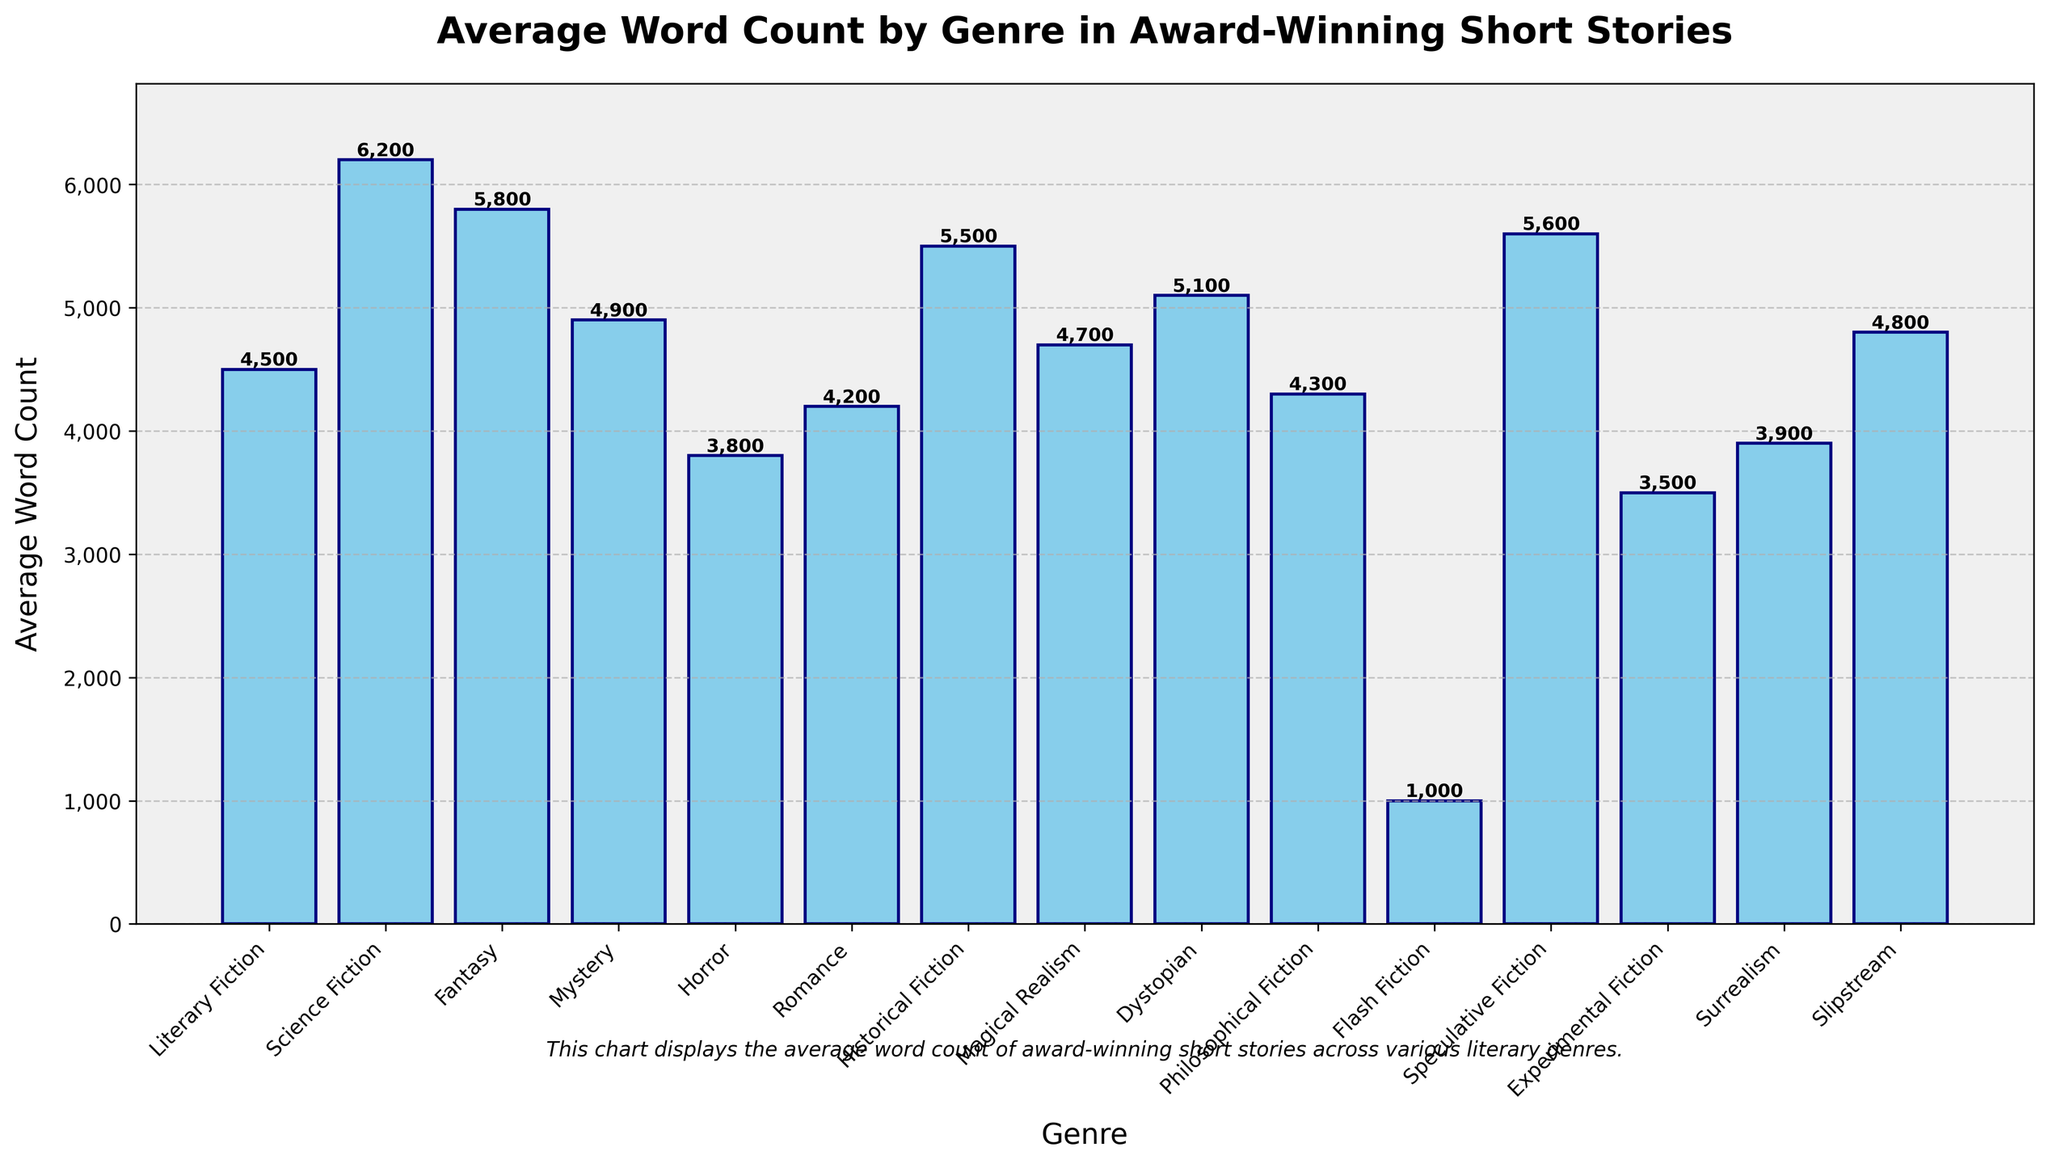What genre has the highest average word count? Look at the height of the bars and identify the tallest one. The tallest bar represents Science Fiction with 6200 words.
Answer: Science Fiction What is the difference in average word count between Science Fiction and Horror? Find the heights of the bars for Science Fiction (6200) and Horror (3800), then subtract the lower from the higher: 6200 - 3800 = 2400.
Answer: 2400 Which genre has a lower average word count, Fantasy or Dystopian? Compare the heights of the bars for Fantasy (5800) and Dystopian (5100). Fantasy is higher, so Dystopian is lower.
Answer: Dystopian How does the average word count of Flash Fiction compare to the other genres? Flash Fiction has an average word count of 1000, which is significantly lower than any other genre in the graph.
Answer: Much lower What are the three genres with the closest average word counts? Look for bars with similar heights. Romance (4200), Philosophical Fiction (4300), and Surrealism (3900) are closest in height.
Answer: Romance, Philosophical Fiction, and Surrealism Which genre has a greater average word count: Historical Fiction or Magical Realism? Compare the heights of the bars for Historical Fiction (5500) and Magical Realism (4700). Historical Fiction is higher.
Answer: Historical Fiction What is the average word count for genres that typically blend reality and fantasy elements, like Surrealism and Magical Realism? Add the word counts for Surrealism (3900) and Magical Realism (4700), then divide by the number of genres (2). (3900 + 4700) / 2 = 4300.
Answer: 4300 How much higher is the average word count of Historical Fiction compared to Romance? Subtract the average word count of Romance (4200) from that of Historical Fiction (5500): 5500 - 4200 = 1300.
Answer: 1300 